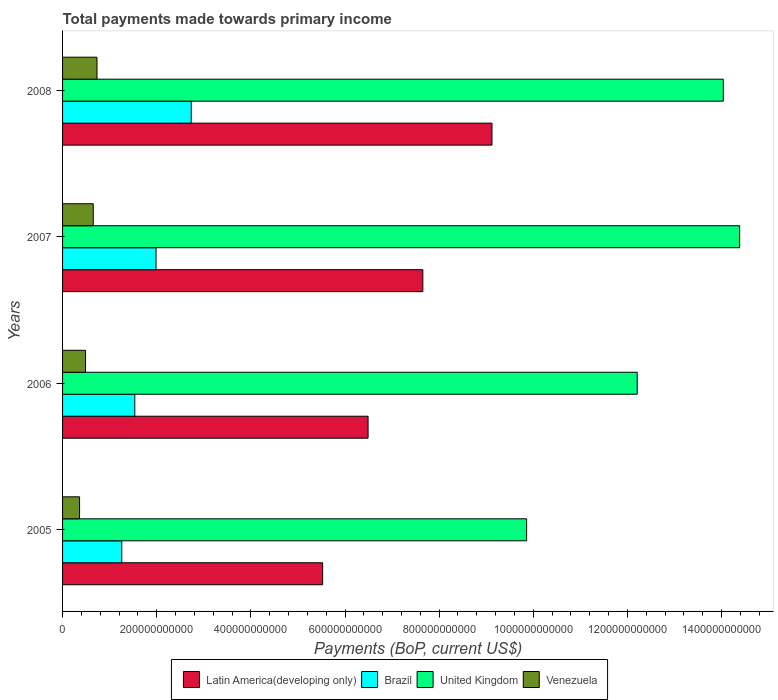How many different coloured bars are there?
Provide a succinct answer. 4. How many groups of bars are there?
Your response must be concise. 4. Are the number of bars on each tick of the Y-axis equal?
Provide a succinct answer. Yes. How many bars are there on the 3rd tick from the top?
Ensure brevity in your answer.  4. What is the label of the 4th group of bars from the top?
Your answer should be very brief. 2005. What is the total payments made towards primary income in Latin America(developing only) in 2005?
Offer a terse response. 5.52e+11. Across all years, what is the maximum total payments made towards primary income in Latin America(developing only)?
Provide a succinct answer. 9.12e+11. Across all years, what is the minimum total payments made towards primary income in Latin America(developing only)?
Offer a very short reply. 5.52e+11. In which year was the total payments made towards primary income in Brazil maximum?
Make the answer very short. 2008. In which year was the total payments made towards primary income in Latin America(developing only) minimum?
Your response must be concise. 2005. What is the total total payments made towards primary income in Latin America(developing only) in the graph?
Make the answer very short. 2.88e+12. What is the difference between the total payments made towards primary income in United Kingdom in 2006 and that in 2007?
Give a very brief answer. -2.18e+11. What is the difference between the total payments made towards primary income in Brazil in 2006 and the total payments made towards primary income in Venezuela in 2008?
Provide a short and direct response. 8.03e+1. What is the average total payments made towards primary income in Brazil per year?
Provide a short and direct response. 1.88e+11. In the year 2008, what is the difference between the total payments made towards primary income in Venezuela and total payments made towards primary income in Latin America(developing only)?
Keep it short and to the point. -8.39e+11. What is the ratio of the total payments made towards primary income in Venezuela in 2005 to that in 2008?
Give a very brief answer. 0.49. What is the difference between the highest and the second highest total payments made towards primary income in Brazil?
Ensure brevity in your answer.  7.47e+1. What is the difference between the highest and the lowest total payments made towards primary income in Venezuela?
Make the answer very short. 3.71e+1. Is the sum of the total payments made towards primary income in United Kingdom in 2005 and 2006 greater than the maximum total payments made towards primary income in Brazil across all years?
Offer a very short reply. Yes. Is it the case that in every year, the sum of the total payments made towards primary income in Latin America(developing only) and total payments made towards primary income in United Kingdom is greater than the sum of total payments made towards primary income in Brazil and total payments made towards primary income in Venezuela?
Provide a short and direct response. No. What does the 4th bar from the top in 2007 represents?
Offer a terse response. Latin America(developing only). Is it the case that in every year, the sum of the total payments made towards primary income in Latin America(developing only) and total payments made towards primary income in Venezuela is greater than the total payments made towards primary income in United Kingdom?
Your response must be concise. No. How many bars are there?
Keep it short and to the point. 16. Are all the bars in the graph horizontal?
Provide a succinct answer. Yes. What is the difference between two consecutive major ticks on the X-axis?
Provide a short and direct response. 2.00e+11. Does the graph contain any zero values?
Your answer should be very brief. No. Does the graph contain grids?
Your answer should be very brief. No. Where does the legend appear in the graph?
Your answer should be very brief. Bottom center. How many legend labels are there?
Keep it short and to the point. 4. How are the legend labels stacked?
Your answer should be very brief. Horizontal. What is the title of the graph?
Your answer should be very brief. Total payments made towards primary income. What is the label or title of the X-axis?
Make the answer very short. Payments (BoP, current US$). What is the label or title of the Y-axis?
Offer a terse response. Years. What is the Payments (BoP, current US$) in Latin America(developing only) in 2005?
Give a very brief answer. 5.52e+11. What is the Payments (BoP, current US$) in Brazil in 2005?
Provide a succinct answer. 1.26e+11. What is the Payments (BoP, current US$) in United Kingdom in 2005?
Offer a terse response. 9.86e+11. What is the Payments (BoP, current US$) in Venezuela in 2005?
Your response must be concise. 3.61e+1. What is the Payments (BoP, current US$) of Latin America(developing only) in 2006?
Offer a terse response. 6.49e+11. What is the Payments (BoP, current US$) of Brazil in 2006?
Offer a terse response. 1.53e+11. What is the Payments (BoP, current US$) of United Kingdom in 2006?
Your response must be concise. 1.22e+12. What is the Payments (BoP, current US$) of Venezuela in 2006?
Provide a succinct answer. 4.88e+1. What is the Payments (BoP, current US$) in Latin America(developing only) in 2007?
Your response must be concise. 7.65e+11. What is the Payments (BoP, current US$) in Brazil in 2007?
Your answer should be compact. 1.99e+11. What is the Payments (BoP, current US$) in United Kingdom in 2007?
Your answer should be compact. 1.44e+12. What is the Payments (BoP, current US$) of Venezuela in 2007?
Provide a succinct answer. 6.52e+1. What is the Payments (BoP, current US$) in Latin America(developing only) in 2008?
Provide a succinct answer. 9.12e+11. What is the Payments (BoP, current US$) in Brazil in 2008?
Keep it short and to the point. 2.73e+11. What is the Payments (BoP, current US$) in United Kingdom in 2008?
Offer a terse response. 1.40e+12. What is the Payments (BoP, current US$) of Venezuela in 2008?
Keep it short and to the point. 7.31e+1. Across all years, what is the maximum Payments (BoP, current US$) in Latin America(developing only)?
Your answer should be very brief. 9.12e+11. Across all years, what is the maximum Payments (BoP, current US$) in Brazil?
Ensure brevity in your answer.  2.73e+11. Across all years, what is the maximum Payments (BoP, current US$) in United Kingdom?
Your answer should be very brief. 1.44e+12. Across all years, what is the maximum Payments (BoP, current US$) of Venezuela?
Offer a very short reply. 7.31e+1. Across all years, what is the minimum Payments (BoP, current US$) of Latin America(developing only)?
Ensure brevity in your answer.  5.52e+11. Across all years, what is the minimum Payments (BoP, current US$) of Brazil?
Keep it short and to the point. 1.26e+11. Across all years, what is the minimum Payments (BoP, current US$) in United Kingdom?
Your answer should be compact. 9.86e+11. Across all years, what is the minimum Payments (BoP, current US$) in Venezuela?
Keep it short and to the point. 3.61e+1. What is the total Payments (BoP, current US$) of Latin America(developing only) in the graph?
Provide a short and direct response. 2.88e+12. What is the total Payments (BoP, current US$) in Brazil in the graph?
Offer a very short reply. 7.51e+11. What is the total Payments (BoP, current US$) in United Kingdom in the graph?
Your answer should be compact. 5.05e+12. What is the total Payments (BoP, current US$) of Venezuela in the graph?
Give a very brief answer. 2.23e+11. What is the difference between the Payments (BoP, current US$) of Latin America(developing only) in 2005 and that in 2006?
Your answer should be very brief. -9.65e+1. What is the difference between the Payments (BoP, current US$) of Brazil in 2005 and that in 2006?
Your answer should be compact. -2.77e+1. What is the difference between the Payments (BoP, current US$) of United Kingdom in 2005 and that in 2006?
Offer a very short reply. -2.35e+11. What is the difference between the Payments (BoP, current US$) in Venezuela in 2005 and that in 2006?
Keep it short and to the point. -1.27e+1. What is the difference between the Payments (BoP, current US$) of Latin America(developing only) in 2005 and that in 2007?
Your response must be concise. -2.13e+11. What is the difference between the Payments (BoP, current US$) of Brazil in 2005 and that in 2007?
Provide a succinct answer. -7.28e+1. What is the difference between the Payments (BoP, current US$) of United Kingdom in 2005 and that in 2007?
Provide a succinct answer. -4.53e+11. What is the difference between the Payments (BoP, current US$) of Venezuela in 2005 and that in 2007?
Keep it short and to the point. -2.91e+1. What is the difference between the Payments (BoP, current US$) of Latin America(developing only) in 2005 and that in 2008?
Your response must be concise. -3.60e+11. What is the difference between the Payments (BoP, current US$) of Brazil in 2005 and that in 2008?
Your response must be concise. -1.48e+11. What is the difference between the Payments (BoP, current US$) of United Kingdom in 2005 and that in 2008?
Provide a succinct answer. -4.18e+11. What is the difference between the Payments (BoP, current US$) in Venezuela in 2005 and that in 2008?
Make the answer very short. -3.71e+1. What is the difference between the Payments (BoP, current US$) of Latin America(developing only) in 2006 and that in 2007?
Offer a terse response. -1.16e+11. What is the difference between the Payments (BoP, current US$) in Brazil in 2006 and that in 2007?
Your answer should be compact. -4.51e+1. What is the difference between the Payments (BoP, current US$) of United Kingdom in 2006 and that in 2007?
Offer a terse response. -2.18e+11. What is the difference between the Payments (BoP, current US$) of Venezuela in 2006 and that in 2007?
Provide a succinct answer. -1.64e+1. What is the difference between the Payments (BoP, current US$) in Latin America(developing only) in 2006 and that in 2008?
Your answer should be very brief. -2.63e+11. What is the difference between the Payments (BoP, current US$) of Brazil in 2006 and that in 2008?
Provide a succinct answer. -1.20e+11. What is the difference between the Payments (BoP, current US$) of United Kingdom in 2006 and that in 2008?
Your answer should be compact. -1.83e+11. What is the difference between the Payments (BoP, current US$) in Venezuela in 2006 and that in 2008?
Ensure brevity in your answer.  -2.43e+1. What is the difference between the Payments (BoP, current US$) of Latin America(developing only) in 2007 and that in 2008?
Offer a very short reply. -1.47e+11. What is the difference between the Payments (BoP, current US$) of Brazil in 2007 and that in 2008?
Make the answer very short. -7.47e+1. What is the difference between the Payments (BoP, current US$) in United Kingdom in 2007 and that in 2008?
Offer a terse response. 3.47e+1. What is the difference between the Payments (BoP, current US$) of Venezuela in 2007 and that in 2008?
Ensure brevity in your answer.  -7.94e+09. What is the difference between the Payments (BoP, current US$) of Latin America(developing only) in 2005 and the Payments (BoP, current US$) of Brazil in 2006?
Your answer should be very brief. 3.99e+11. What is the difference between the Payments (BoP, current US$) in Latin America(developing only) in 2005 and the Payments (BoP, current US$) in United Kingdom in 2006?
Offer a terse response. -6.68e+11. What is the difference between the Payments (BoP, current US$) of Latin America(developing only) in 2005 and the Payments (BoP, current US$) of Venezuela in 2006?
Offer a terse response. 5.04e+11. What is the difference between the Payments (BoP, current US$) of Brazil in 2005 and the Payments (BoP, current US$) of United Kingdom in 2006?
Ensure brevity in your answer.  -1.09e+12. What is the difference between the Payments (BoP, current US$) in Brazil in 2005 and the Payments (BoP, current US$) in Venezuela in 2006?
Offer a terse response. 7.70e+1. What is the difference between the Payments (BoP, current US$) in United Kingdom in 2005 and the Payments (BoP, current US$) in Venezuela in 2006?
Offer a terse response. 9.37e+11. What is the difference between the Payments (BoP, current US$) of Latin America(developing only) in 2005 and the Payments (BoP, current US$) of Brazil in 2007?
Provide a short and direct response. 3.54e+11. What is the difference between the Payments (BoP, current US$) in Latin America(developing only) in 2005 and the Payments (BoP, current US$) in United Kingdom in 2007?
Ensure brevity in your answer.  -8.86e+11. What is the difference between the Payments (BoP, current US$) of Latin America(developing only) in 2005 and the Payments (BoP, current US$) of Venezuela in 2007?
Offer a very short reply. 4.87e+11. What is the difference between the Payments (BoP, current US$) in Brazil in 2005 and the Payments (BoP, current US$) in United Kingdom in 2007?
Your answer should be compact. -1.31e+12. What is the difference between the Payments (BoP, current US$) of Brazil in 2005 and the Payments (BoP, current US$) of Venezuela in 2007?
Provide a succinct answer. 6.06e+1. What is the difference between the Payments (BoP, current US$) of United Kingdom in 2005 and the Payments (BoP, current US$) of Venezuela in 2007?
Offer a very short reply. 9.21e+11. What is the difference between the Payments (BoP, current US$) of Latin America(developing only) in 2005 and the Payments (BoP, current US$) of Brazil in 2008?
Provide a short and direct response. 2.79e+11. What is the difference between the Payments (BoP, current US$) of Latin America(developing only) in 2005 and the Payments (BoP, current US$) of United Kingdom in 2008?
Offer a terse response. -8.51e+11. What is the difference between the Payments (BoP, current US$) of Latin America(developing only) in 2005 and the Payments (BoP, current US$) of Venezuela in 2008?
Your answer should be very brief. 4.79e+11. What is the difference between the Payments (BoP, current US$) of Brazil in 2005 and the Payments (BoP, current US$) of United Kingdom in 2008?
Your answer should be very brief. -1.28e+12. What is the difference between the Payments (BoP, current US$) of Brazil in 2005 and the Payments (BoP, current US$) of Venezuela in 2008?
Keep it short and to the point. 5.26e+1. What is the difference between the Payments (BoP, current US$) in United Kingdom in 2005 and the Payments (BoP, current US$) in Venezuela in 2008?
Give a very brief answer. 9.13e+11. What is the difference between the Payments (BoP, current US$) in Latin America(developing only) in 2006 and the Payments (BoP, current US$) in Brazil in 2007?
Give a very brief answer. 4.50e+11. What is the difference between the Payments (BoP, current US$) in Latin America(developing only) in 2006 and the Payments (BoP, current US$) in United Kingdom in 2007?
Make the answer very short. -7.89e+11. What is the difference between the Payments (BoP, current US$) in Latin America(developing only) in 2006 and the Payments (BoP, current US$) in Venezuela in 2007?
Make the answer very short. 5.84e+11. What is the difference between the Payments (BoP, current US$) of Brazil in 2006 and the Payments (BoP, current US$) of United Kingdom in 2007?
Keep it short and to the point. -1.28e+12. What is the difference between the Payments (BoP, current US$) of Brazil in 2006 and the Payments (BoP, current US$) of Venezuela in 2007?
Your answer should be compact. 8.82e+1. What is the difference between the Payments (BoP, current US$) in United Kingdom in 2006 and the Payments (BoP, current US$) in Venezuela in 2007?
Your answer should be compact. 1.16e+12. What is the difference between the Payments (BoP, current US$) of Latin America(developing only) in 2006 and the Payments (BoP, current US$) of Brazil in 2008?
Provide a succinct answer. 3.76e+11. What is the difference between the Payments (BoP, current US$) of Latin America(developing only) in 2006 and the Payments (BoP, current US$) of United Kingdom in 2008?
Offer a terse response. -7.55e+11. What is the difference between the Payments (BoP, current US$) of Latin America(developing only) in 2006 and the Payments (BoP, current US$) of Venezuela in 2008?
Provide a short and direct response. 5.76e+11. What is the difference between the Payments (BoP, current US$) in Brazil in 2006 and the Payments (BoP, current US$) in United Kingdom in 2008?
Offer a terse response. -1.25e+12. What is the difference between the Payments (BoP, current US$) in Brazil in 2006 and the Payments (BoP, current US$) in Venezuela in 2008?
Offer a very short reply. 8.03e+1. What is the difference between the Payments (BoP, current US$) in United Kingdom in 2006 and the Payments (BoP, current US$) in Venezuela in 2008?
Provide a short and direct response. 1.15e+12. What is the difference between the Payments (BoP, current US$) of Latin America(developing only) in 2007 and the Payments (BoP, current US$) of Brazil in 2008?
Ensure brevity in your answer.  4.92e+11. What is the difference between the Payments (BoP, current US$) in Latin America(developing only) in 2007 and the Payments (BoP, current US$) in United Kingdom in 2008?
Offer a terse response. -6.38e+11. What is the difference between the Payments (BoP, current US$) in Latin America(developing only) in 2007 and the Payments (BoP, current US$) in Venezuela in 2008?
Offer a terse response. 6.92e+11. What is the difference between the Payments (BoP, current US$) in Brazil in 2007 and the Payments (BoP, current US$) in United Kingdom in 2008?
Make the answer very short. -1.21e+12. What is the difference between the Payments (BoP, current US$) in Brazil in 2007 and the Payments (BoP, current US$) in Venezuela in 2008?
Offer a very short reply. 1.25e+11. What is the difference between the Payments (BoP, current US$) of United Kingdom in 2007 and the Payments (BoP, current US$) of Venezuela in 2008?
Provide a succinct answer. 1.37e+12. What is the average Payments (BoP, current US$) in Latin America(developing only) per year?
Make the answer very short. 7.20e+11. What is the average Payments (BoP, current US$) in Brazil per year?
Give a very brief answer. 1.88e+11. What is the average Payments (BoP, current US$) in United Kingdom per year?
Offer a terse response. 1.26e+12. What is the average Payments (BoP, current US$) of Venezuela per year?
Your response must be concise. 5.58e+1. In the year 2005, what is the difference between the Payments (BoP, current US$) of Latin America(developing only) and Payments (BoP, current US$) of Brazil?
Provide a succinct answer. 4.27e+11. In the year 2005, what is the difference between the Payments (BoP, current US$) in Latin America(developing only) and Payments (BoP, current US$) in United Kingdom?
Ensure brevity in your answer.  -4.33e+11. In the year 2005, what is the difference between the Payments (BoP, current US$) of Latin America(developing only) and Payments (BoP, current US$) of Venezuela?
Keep it short and to the point. 5.16e+11. In the year 2005, what is the difference between the Payments (BoP, current US$) in Brazil and Payments (BoP, current US$) in United Kingdom?
Ensure brevity in your answer.  -8.60e+11. In the year 2005, what is the difference between the Payments (BoP, current US$) of Brazil and Payments (BoP, current US$) of Venezuela?
Offer a very short reply. 8.97e+1. In the year 2005, what is the difference between the Payments (BoP, current US$) in United Kingdom and Payments (BoP, current US$) in Venezuela?
Your response must be concise. 9.50e+11. In the year 2006, what is the difference between the Payments (BoP, current US$) of Latin America(developing only) and Payments (BoP, current US$) of Brazil?
Ensure brevity in your answer.  4.96e+11. In the year 2006, what is the difference between the Payments (BoP, current US$) in Latin America(developing only) and Payments (BoP, current US$) in United Kingdom?
Provide a succinct answer. -5.72e+11. In the year 2006, what is the difference between the Payments (BoP, current US$) in Latin America(developing only) and Payments (BoP, current US$) in Venezuela?
Your response must be concise. 6.00e+11. In the year 2006, what is the difference between the Payments (BoP, current US$) in Brazil and Payments (BoP, current US$) in United Kingdom?
Offer a terse response. -1.07e+12. In the year 2006, what is the difference between the Payments (BoP, current US$) of Brazil and Payments (BoP, current US$) of Venezuela?
Your answer should be compact. 1.05e+11. In the year 2006, what is the difference between the Payments (BoP, current US$) in United Kingdom and Payments (BoP, current US$) in Venezuela?
Your response must be concise. 1.17e+12. In the year 2007, what is the difference between the Payments (BoP, current US$) in Latin America(developing only) and Payments (BoP, current US$) in Brazil?
Your response must be concise. 5.67e+11. In the year 2007, what is the difference between the Payments (BoP, current US$) of Latin America(developing only) and Payments (BoP, current US$) of United Kingdom?
Give a very brief answer. -6.73e+11. In the year 2007, what is the difference between the Payments (BoP, current US$) in Latin America(developing only) and Payments (BoP, current US$) in Venezuela?
Your answer should be very brief. 7.00e+11. In the year 2007, what is the difference between the Payments (BoP, current US$) in Brazil and Payments (BoP, current US$) in United Kingdom?
Your answer should be compact. -1.24e+12. In the year 2007, what is the difference between the Payments (BoP, current US$) of Brazil and Payments (BoP, current US$) of Venezuela?
Give a very brief answer. 1.33e+11. In the year 2007, what is the difference between the Payments (BoP, current US$) in United Kingdom and Payments (BoP, current US$) in Venezuela?
Your answer should be compact. 1.37e+12. In the year 2008, what is the difference between the Payments (BoP, current US$) in Latin America(developing only) and Payments (BoP, current US$) in Brazil?
Provide a short and direct response. 6.39e+11. In the year 2008, what is the difference between the Payments (BoP, current US$) in Latin America(developing only) and Payments (BoP, current US$) in United Kingdom?
Provide a succinct answer. -4.91e+11. In the year 2008, what is the difference between the Payments (BoP, current US$) of Latin America(developing only) and Payments (BoP, current US$) of Venezuela?
Provide a short and direct response. 8.39e+11. In the year 2008, what is the difference between the Payments (BoP, current US$) of Brazil and Payments (BoP, current US$) of United Kingdom?
Offer a very short reply. -1.13e+12. In the year 2008, what is the difference between the Payments (BoP, current US$) of Brazil and Payments (BoP, current US$) of Venezuela?
Provide a succinct answer. 2.00e+11. In the year 2008, what is the difference between the Payments (BoP, current US$) of United Kingdom and Payments (BoP, current US$) of Venezuela?
Ensure brevity in your answer.  1.33e+12. What is the ratio of the Payments (BoP, current US$) in Latin America(developing only) in 2005 to that in 2006?
Offer a terse response. 0.85. What is the ratio of the Payments (BoP, current US$) in Brazil in 2005 to that in 2006?
Give a very brief answer. 0.82. What is the ratio of the Payments (BoP, current US$) in United Kingdom in 2005 to that in 2006?
Ensure brevity in your answer.  0.81. What is the ratio of the Payments (BoP, current US$) of Venezuela in 2005 to that in 2006?
Keep it short and to the point. 0.74. What is the ratio of the Payments (BoP, current US$) in Latin America(developing only) in 2005 to that in 2007?
Your answer should be very brief. 0.72. What is the ratio of the Payments (BoP, current US$) of Brazil in 2005 to that in 2007?
Keep it short and to the point. 0.63. What is the ratio of the Payments (BoP, current US$) of United Kingdom in 2005 to that in 2007?
Give a very brief answer. 0.69. What is the ratio of the Payments (BoP, current US$) in Venezuela in 2005 to that in 2007?
Offer a terse response. 0.55. What is the ratio of the Payments (BoP, current US$) in Latin America(developing only) in 2005 to that in 2008?
Provide a succinct answer. 0.61. What is the ratio of the Payments (BoP, current US$) of Brazil in 2005 to that in 2008?
Your answer should be very brief. 0.46. What is the ratio of the Payments (BoP, current US$) in United Kingdom in 2005 to that in 2008?
Your response must be concise. 0.7. What is the ratio of the Payments (BoP, current US$) of Venezuela in 2005 to that in 2008?
Your answer should be very brief. 0.49. What is the ratio of the Payments (BoP, current US$) of Latin America(developing only) in 2006 to that in 2007?
Give a very brief answer. 0.85. What is the ratio of the Payments (BoP, current US$) in Brazil in 2006 to that in 2007?
Keep it short and to the point. 0.77. What is the ratio of the Payments (BoP, current US$) of United Kingdom in 2006 to that in 2007?
Offer a very short reply. 0.85. What is the ratio of the Payments (BoP, current US$) of Venezuela in 2006 to that in 2007?
Provide a succinct answer. 0.75. What is the ratio of the Payments (BoP, current US$) of Latin America(developing only) in 2006 to that in 2008?
Ensure brevity in your answer.  0.71. What is the ratio of the Payments (BoP, current US$) in Brazil in 2006 to that in 2008?
Make the answer very short. 0.56. What is the ratio of the Payments (BoP, current US$) in United Kingdom in 2006 to that in 2008?
Ensure brevity in your answer.  0.87. What is the ratio of the Payments (BoP, current US$) in Venezuela in 2006 to that in 2008?
Your answer should be very brief. 0.67. What is the ratio of the Payments (BoP, current US$) in Latin America(developing only) in 2007 to that in 2008?
Provide a succinct answer. 0.84. What is the ratio of the Payments (BoP, current US$) of Brazil in 2007 to that in 2008?
Your answer should be compact. 0.73. What is the ratio of the Payments (BoP, current US$) of United Kingdom in 2007 to that in 2008?
Make the answer very short. 1.02. What is the ratio of the Payments (BoP, current US$) in Venezuela in 2007 to that in 2008?
Your answer should be very brief. 0.89. What is the difference between the highest and the second highest Payments (BoP, current US$) of Latin America(developing only)?
Provide a succinct answer. 1.47e+11. What is the difference between the highest and the second highest Payments (BoP, current US$) of Brazil?
Your response must be concise. 7.47e+1. What is the difference between the highest and the second highest Payments (BoP, current US$) in United Kingdom?
Your answer should be very brief. 3.47e+1. What is the difference between the highest and the second highest Payments (BoP, current US$) of Venezuela?
Give a very brief answer. 7.94e+09. What is the difference between the highest and the lowest Payments (BoP, current US$) in Latin America(developing only)?
Ensure brevity in your answer.  3.60e+11. What is the difference between the highest and the lowest Payments (BoP, current US$) in Brazil?
Your answer should be very brief. 1.48e+11. What is the difference between the highest and the lowest Payments (BoP, current US$) of United Kingdom?
Provide a succinct answer. 4.53e+11. What is the difference between the highest and the lowest Payments (BoP, current US$) in Venezuela?
Ensure brevity in your answer.  3.71e+1. 